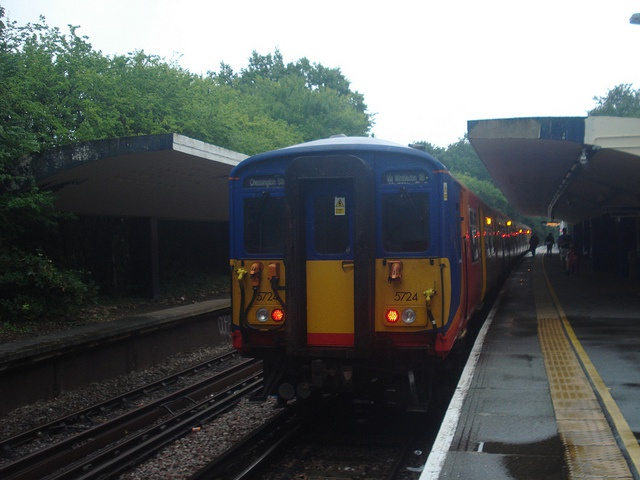Describe the objects in this image and their specific colors. I can see train in white, black, navy, maroon, and olive tones, people in white, black, gray, and darkblue tones, people in white, black, gray, and purple tones, and people in white, black, navy, purple, and blue tones in this image. 